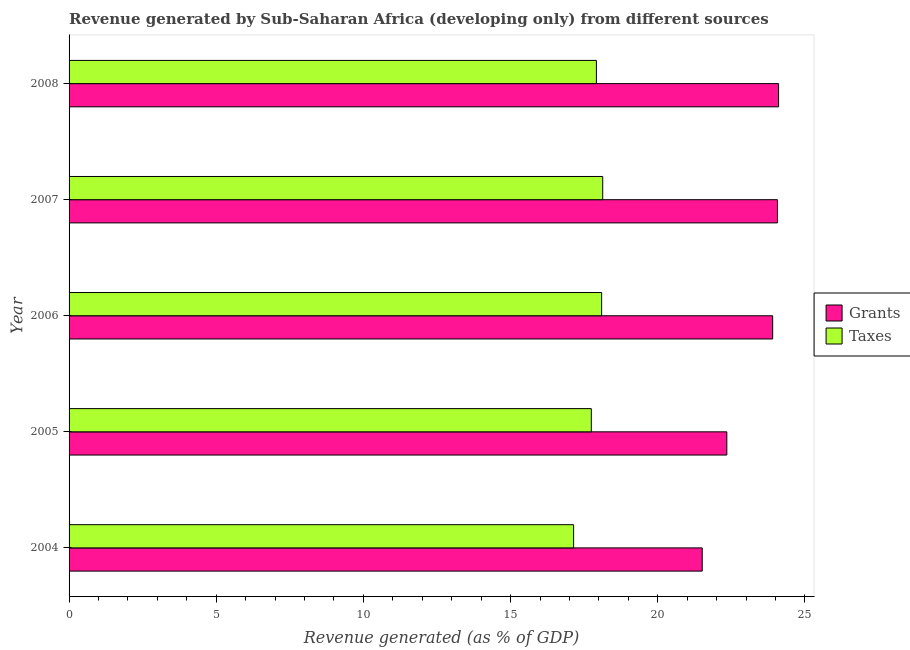Are the number of bars per tick equal to the number of legend labels?
Keep it short and to the point. Yes. What is the label of the 1st group of bars from the top?
Make the answer very short. 2008. In how many cases, is the number of bars for a given year not equal to the number of legend labels?
Provide a succinct answer. 0. What is the revenue generated by taxes in 2008?
Offer a terse response. 17.92. Across all years, what is the maximum revenue generated by grants?
Ensure brevity in your answer.  24.1. Across all years, what is the minimum revenue generated by taxes?
Your answer should be compact. 17.14. In which year was the revenue generated by grants minimum?
Ensure brevity in your answer.  2004. What is the total revenue generated by taxes in the graph?
Your answer should be very brief. 89.02. What is the difference between the revenue generated by grants in 2004 and that in 2005?
Offer a terse response. -0.84. What is the difference between the revenue generated by grants in 2006 and the revenue generated by taxes in 2005?
Offer a terse response. 6.16. What is the average revenue generated by grants per year?
Your answer should be compact. 23.19. In the year 2006, what is the difference between the revenue generated by grants and revenue generated by taxes?
Make the answer very short. 5.81. In how many years, is the revenue generated by taxes greater than 6 %?
Your response must be concise. 5. What is the ratio of the revenue generated by grants in 2004 to that in 2006?
Offer a terse response. 0.9. Is the revenue generated by taxes in 2005 less than that in 2006?
Offer a very short reply. Yes. What is the difference between the highest and the second highest revenue generated by taxes?
Ensure brevity in your answer.  0.04. Is the sum of the revenue generated by grants in 2004 and 2007 greater than the maximum revenue generated by taxes across all years?
Your answer should be very brief. Yes. What does the 1st bar from the top in 2004 represents?
Give a very brief answer. Taxes. What does the 2nd bar from the bottom in 2004 represents?
Make the answer very short. Taxes. How many bars are there?
Offer a terse response. 10. What is the difference between two consecutive major ticks on the X-axis?
Offer a terse response. 5. Are the values on the major ticks of X-axis written in scientific E-notation?
Keep it short and to the point. No. How are the legend labels stacked?
Your response must be concise. Vertical. What is the title of the graph?
Your answer should be very brief. Revenue generated by Sub-Saharan Africa (developing only) from different sources. What is the label or title of the X-axis?
Ensure brevity in your answer.  Revenue generated (as % of GDP). What is the Revenue generated (as % of GDP) in Grants in 2004?
Your response must be concise. 21.51. What is the Revenue generated (as % of GDP) of Taxes in 2004?
Your answer should be very brief. 17.14. What is the Revenue generated (as % of GDP) of Grants in 2005?
Your answer should be compact. 22.35. What is the Revenue generated (as % of GDP) in Taxes in 2005?
Provide a short and direct response. 17.74. What is the Revenue generated (as % of GDP) of Grants in 2006?
Provide a short and direct response. 23.9. What is the Revenue generated (as % of GDP) in Taxes in 2006?
Offer a very short reply. 18.09. What is the Revenue generated (as % of GDP) of Grants in 2007?
Provide a short and direct response. 24.07. What is the Revenue generated (as % of GDP) of Taxes in 2007?
Make the answer very short. 18.13. What is the Revenue generated (as % of GDP) of Grants in 2008?
Give a very brief answer. 24.1. What is the Revenue generated (as % of GDP) in Taxes in 2008?
Your answer should be compact. 17.92. Across all years, what is the maximum Revenue generated (as % of GDP) in Grants?
Ensure brevity in your answer.  24.1. Across all years, what is the maximum Revenue generated (as % of GDP) of Taxes?
Your answer should be very brief. 18.13. Across all years, what is the minimum Revenue generated (as % of GDP) of Grants?
Your answer should be compact. 21.51. Across all years, what is the minimum Revenue generated (as % of GDP) in Taxes?
Your answer should be very brief. 17.14. What is the total Revenue generated (as % of GDP) of Grants in the graph?
Give a very brief answer. 115.93. What is the total Revenue generated (as % of GDP) of Taxes in the graph?
Provide a short and direct response. 89.02. What is the difference between the Revenue generated (as % of GDP) in Grants in 2004 and that in 2005?
Offer a very short reply. -0.84. What is the difference between the Revenue generated (as % of GDP) in Taxes in 2004 and that in 2005?
Your answer should be compact. -0.6. What is the difference between the Revenue generated (as % of GDP) in Grants in 2004 and that in 2006?
Provide a short and direct response. -2.39. What is the difference between the Revenue generated (as % of GDP) in Taxes in 2004 and that in 2006?
Make the answer very short. -0.95. What is the difference between the Revenue generated (as % of GDP) of Grants in 2004 and that in 2007?
Offer a very short reply. -2.56. What is the difference between the Revenue generated (as % of GDP) in Taxes in 2004 and that in 2007?
Offer a terse response. -0.99. What is the difference between the Revenue generated (as % of GDP) of Grants in 2004 and that in 2008?
Provide a short and direct response. -2.59. What is the difference between the Revenue generated (as % of GDP) in Taxes in 2004 and that in 2008?
Offer a very short reply. -0.77. What is the difference between the Revenue generated (as % of GDP) of Grants in 2005 and that in 2006?
Offer a very short reply. -1.56. What is the difference between the Revenue generated (as % of GDP) of Taxes in 2005 and that in 2006?
Provide a short and direct response. -0.35. What is the difference between the Revenue generated (as % of GDP) of Grants in 2005 and that in 2007?
Your response must be concise. -1.72. What is the difference between the Revenue generated (as % of GDP) of Taxes in 2005 and that in 2007?
Keep it short and to the point. -0.39. What is the difference between the Revenue generated (as % of GDP) in Grants in 2005 and that in 2008?
Your answer should be very brief. -1.76. What is the difference between the Revenue generated (as % of GDP) in Taxes in 2005 and that in 2008?
Ensure brevity in your answer.  -0.17. What is the difference between the Revenue generated (as % of GDP) in Grants in 2006 and that in 2007?
Offer a terse response. -0.16. What is the difference between the Revenue generated (as % of GDP) in Taxes in 2006 and that in 2007?
Give a very brief answer. -0.04. What is the difference between the Revenue generated (as % of GDP) of Grants in 2006 and that in 2008?
Keep it short and to the point. -0.2. What is the difference between the Revenue generated (as % of GDP) in Taxes in 2006 and that in 2008?
Your response must be concise. 0.18. What is the difference between the Revenue generated (as % of GDP) of Grants in 2007 and that in 2008?
Offer a terse response. -0.04. What is the difference between the Revenue generated (as % of GDP) in Taxes in 2007 and that in 2008?
Provide a short and direct response. 0.21. What is the difference between the Revenue generated (as % of GDP) in Grants in 2004 and the Revenue generated (as % of GDP) in Taxes in 2005?
Provide a succinct answer. 3.77. What is the difference between the Revenue generated (as % of GDP) of Grants in 2004 and the Revenue generated (as % of GDP) of Taxes in 2006?
Keep it short and to the point. 3.42. What is the difference between the Revenue generated (as % of GDP) in Grants in 2004 and the Revenue generated (as % of GDP) in Taxes in 2007?
Make the answer very short. 3.38. What is the difference between the Revenue generated (as % of GDP) of Grants in 2004 and the Revenue generated (as % of GDP) of Taxes in 2008?
Provide a succinct answer. 3.6. What is the difference between the Revenue generated (as % of GDP) in Grants in 2005 and the Revenue generated (as % of GDP) in Taxes in 2006?
Your response must be concise. 4.25. What is the difference between the Revenue generated (as % of GDP) of Grants in 2005 and the Revenue generated (as % of GDP) of Taxes in 2007?
Give a very brief answer. 4.22. What is the difference between the Revenue generated (as % of GDP) of Grants in 2005 and the Revenue generated (as % of GDP) of Taxes in 2008?
Provide a short and direct response. 4.43. What is the difference between the Revenue generated (as % of GDP) in Grants in 2006 and the Revenue generated (as % of GDP) in Taxes in 2007?
Give a very brief answer. 5.77. What is the difference between the Revenue generated (as % of GDP) in Grants in 2006 and the Revenue generated (as % of GDP) in Taxes in 2008?
Your answer should be compact. 5.99. What is the difference between the Revenue generated (as % of GDP) in Grants in 2007 and the Revenue generated (as % of GDP) in Taxes in 2008?
Provide a short and direct response. 6.15. What is the average Revenue generated (as % of GDP) in Grants per year?
Provide a short and direct response. 23.19. What is the average Revenue generated (as % of GDP) in Taxes per year?
Your response must be concise. 17.8. In the year 2004, what is the difference between the Revenue generated (as % of GDP) in Grants and Revenue generated (as % of GDP) in Taxes?
Your answer should be compact. 4.37. In the year 2005, what is the difference between the Revenue generated (as % of GDP) in Grants and Revenue generated (as % of GDP) in Taxes?
Provide a short and direct response. 4.6. In the year 2006, what is the difference between the Revenue generated (as % of GDP) in Grants and Revenue generated (as % of GDP) in Taxes?
Ensure brevity in your answer.  5.81. In the year 2007, what is the difference between the Revenue generated (as % of GDP) of Grants and Revenue generated (as % of GDP) of Taxes?
Your response must be concise. 5.94. In the year 2008, what is the difference between the Revenue generated (as % of GDP) in Grants and Revenue generated (as % of GDP) in Taxes?
Your answer should be compact. 6.19. What is the ratio of the Revenue generated (as % of GDP) of Grants in 2004 to that in 2005?
Provide a succinct answer. 0.96. What is the ratio of the Revenue generated (as % of GDP) in Taxes in 2004 to that in 2005?
Your answer should be compact. 0.97. What is the ratio of the Revenue generated (as % of GDP) in Grants in 2004 to that in 2006?
Provide a succinct answer. 0.9. What is the ratio of the Revenue generated (as % of GDP) in Taxes in 2004 to that in 2006?
Offer a terse response. 0.95. What is the ratio of the Revenue generated (as % of GDP) of Grants in 2004 to that in 2007?
Provide a short and direct response. 0.89. What is the ratio of the Revenue generated (as % of GDP) in Taxes in 2004 to that in 2007?
Provide a short and direct response. 0.95. What is the ratio of the Revenue generated (as % of GDP) in Grants in 2004 to that in 2008?
Provide a succinct answer. 0.89. What is the ratio of the Revenue generated (as % of GDP) in Taxes in 2004 to that in 2008?
Keep it short and to the point. 0.96. What is the ratio of the Revenue generated (as % of GDP) of Grants in 2005 to that in 2006?
Ensure brevity in your answer.  0.93. What is the ratio of the Revenue generated (as % of GDP) in Taxes in 2005 to that in 2006?
Make the answer very short. 0.98. What is the ratio of the Revenue generated (as % of GDP) of Grants in 2005 to that in 2007?
Your answer should be compact. 0.93. What is the ratio of the Revenue generated (as % of GDP) in Taxes in 2005 to that in 2007?
Offer a very short reply. 0.98. What is the ratio of the Revenue generated (as % of GDP) of Grants in 2005 to that in 2008?
Give a very brief answer. 0.93. What is the ratio of the Revenue generated (as % of GDP) in Taxes in 2006 to that in 2008?
Your response must be concise. 1.01. What is the difference between the highest and the second highest Revenue generated (as % of GDP) in Grants?
Your response must be concise. 0.04. What is the difference between the highest and the second highest Revenue generated (as % of GDP) in Taxes?
Offer a very short reply. 0.04. What is the difference between the highest and the lowest Revenue generated (as % of GDP) in Grants?
Your answer should be compact. 2.59. 